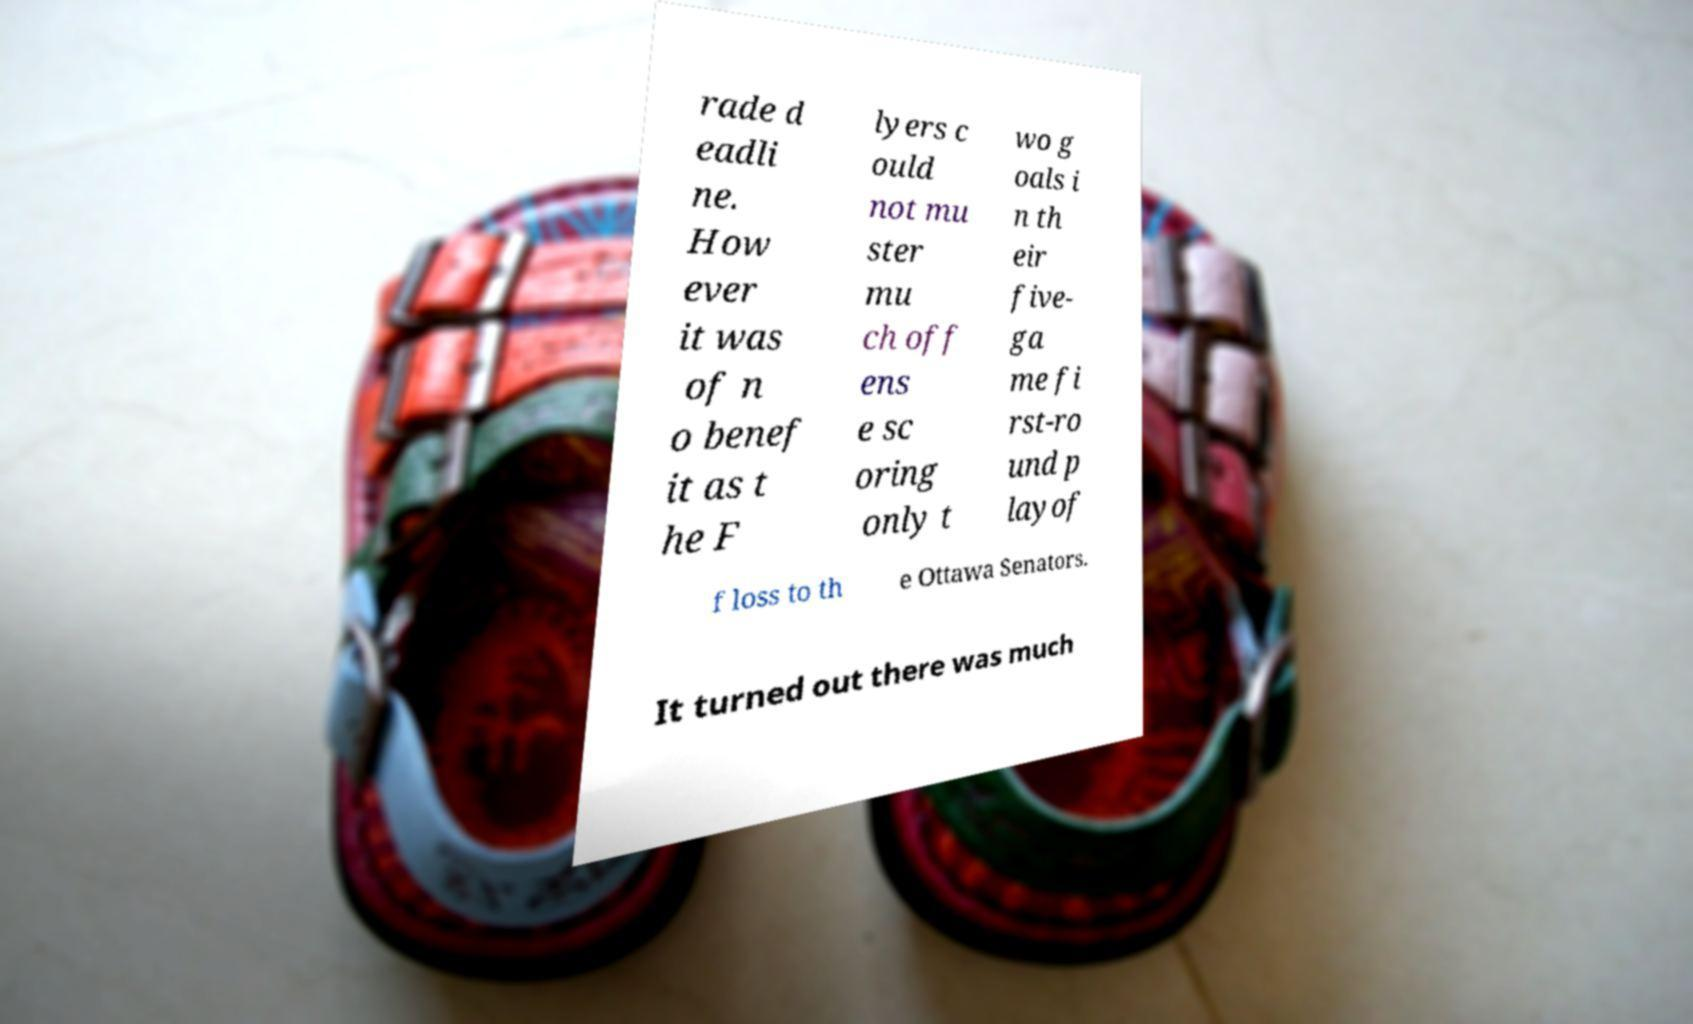Please identify and transcribe the text found in this image. rade d eadli ne. How ever it was of n o benef it as t he F lyers c ould not mu ster mu ch off ens e sc oring only t wo g oals i n th eir five- ga me fi rst-ro und p layof f loss to th e Ottawa Senators. It turned out there was much 